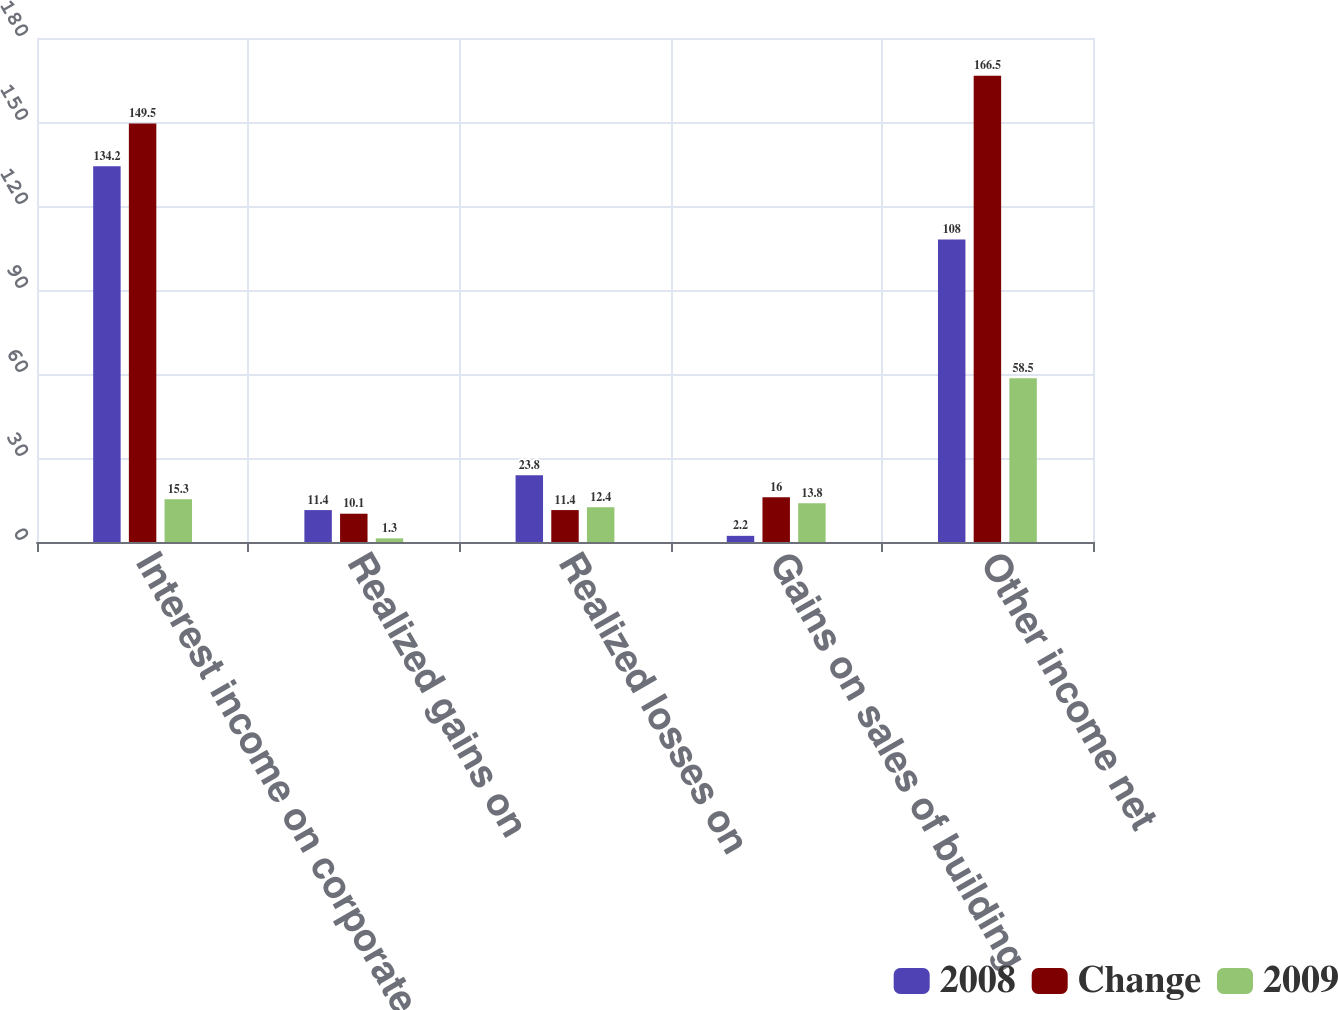<chart> <loc_0><loc_0><loc_500><loc_500><stacked_bar_chart><ecel><fcel>Interest income on corporate<fcel>Realized gains on<fcel>Realized losses on<fcel>Gains on sales of building<fcel>Other income net<nl><fcel>2008<fcel>134.2<fcel>11.4<fcel>23.8<fcel>2.2<fcel>108<nl><fcel>Change<fcel>149.5<fcel>10.1<fcel>11.4<fcel>16<fcel>166.5<nl><fcel>2009<fcel>15.3<fcel>1.3<fcel>12.4<fcel>13.8<fcel>58.5<nl></chart> 